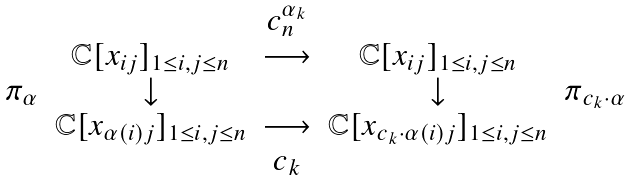<formula> <loc_0><loc_0><loc_500><loc_500>\begin{array} { c c c c c } & & c _ { n } ^ { \alpha _ { k } } & & \\ & \mathbb { C } [ x _ { i j } ] _ { 1 \leq i , j \leq n } & \longrightarrow & \mathbb { C } [ x _ { i j } ] _ { 1 \leq i , j \leq n } & \\ \pi _ { \alpha } & \downarrow & & \downarrow & \pi _ { c _ { k } \cdot \alpha } \\ & \mathbb { C } [ x _ { \alpha ( i ) j } ] _ { 1 \leq i , j \leq n } & \longrightarrow & \mathbb { C } [ x _ { c _ { k } \cdot \alpha ( i ) j } ] _ { 1 \leq i , j \leq n } & \\ & & c _ { k } & & \end{array}</formula> 